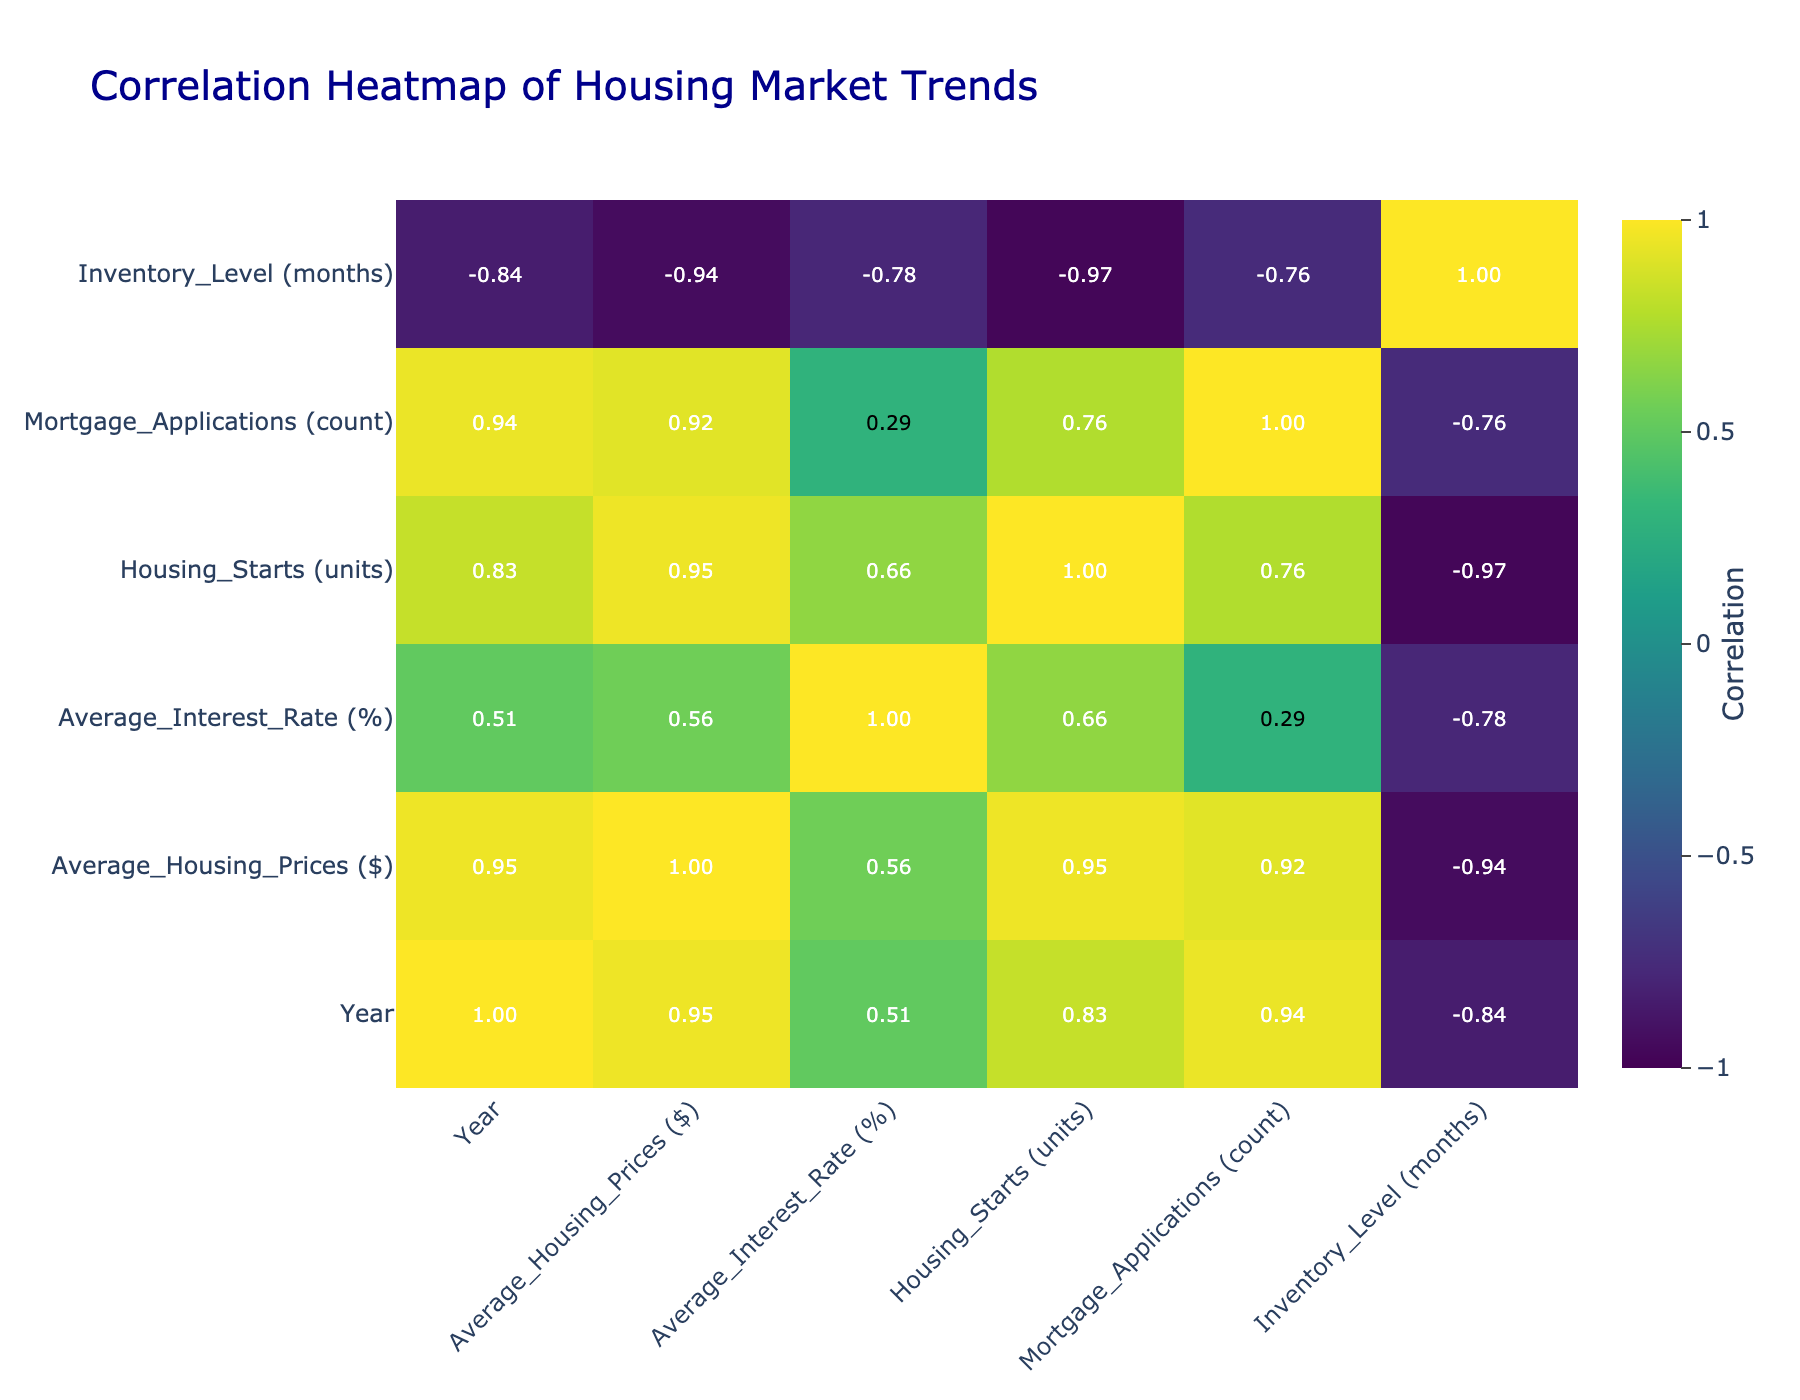What were the average housing prices in 2021? From the table, the row for the year 2021 shows the average housing price is $350,000.
Answer: 350000 What is the average interest rate from 2018 to 2023? The average interest rates over the years are (4.5 + 4.3 + 3.5 + 3.0 + 5.0 + 6.5) = 26.8. Dividing by the number of years (6), the average interest rate is 26.8 / 6 ≈ 4.47.
Answer: 4.47 Did housing prices increase every year from 2018 to 2023? By examining the average housing prices for each year, we see that they increased from $300,000 in 2018 to $380,000 in 2023, indicating consistent annual growth.
Answer: Yes What was the correlation between average housing prices and average interest rates? The correlation matrix shows a negative correlation value between average housing prices and average interest rates, implying that as one increases, the other tends to decrease.
Answer: Negative correlation How many housing starts were there in 2020 compared to 2022? From the table, the number of housing starts in 2020 was 1,100,000 and in 2022 it was 1,500,000. The difference is (1,500,000 - 1,100,000) = 400,000.
Answer: 400000 What was the trend in mortgage applications from 2018 to 2023? By reviewing the data, mortgage applications increased from 500,000 in 2018 to 720,000 in 2023, suggesting a general upward trend in applications over these years.
Answer: Upward trend Was the inventory level lowest in 2023? Checking the inventory levels for all years, we find 5.4, 5.2, 6.0, 4.8, 3.6, and 3.0 months, making 3.0 months in 2023 the lowest among them.
Answer: Yes What was the total number of housing starts over the six years? To find the total, we sum the housing starts from 2018 to 2023: 1,200,000 + 1,300,000 + 1,100,000 + 1,400,000 + 1,500,000 + 1,600,000 = 7,100,000.
Answer: 7100000 What was the change in average interest rates between 2020 and 2023? From the table, the average interest rate in 2020 was 3.5% and in 2023 it was 6.5%. The change is calculated as (6.5 - 3.5) = 3.0%.
Answer: 3.0% 